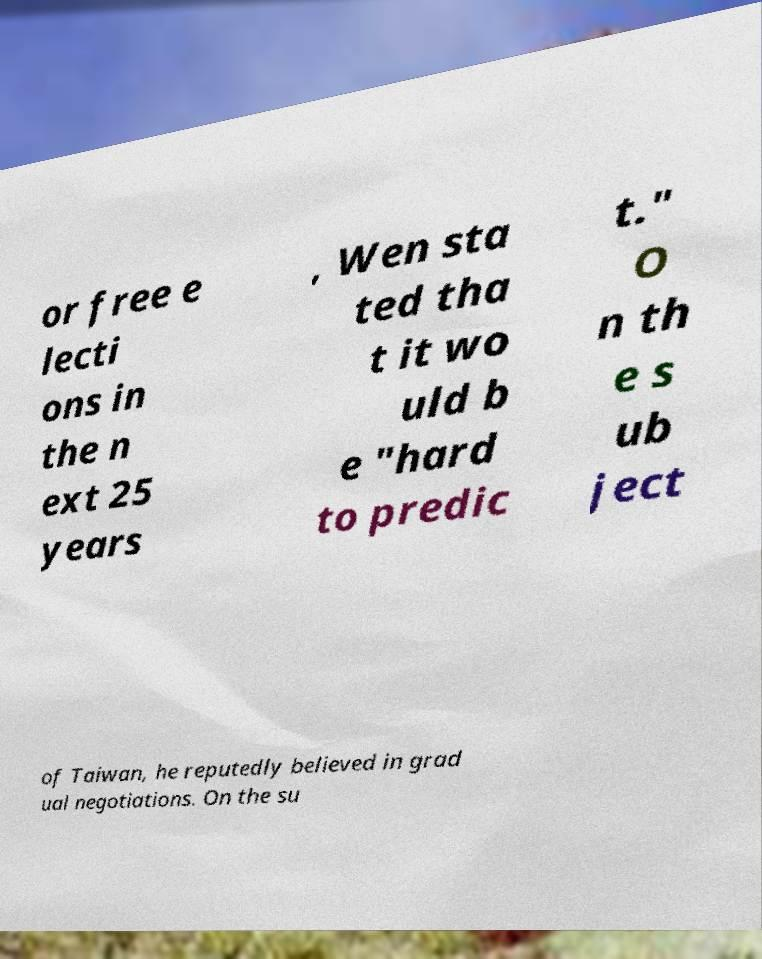Could you extract and type out the text from this image? or free e lecti ons in the n ext 25 years , Wen sta ted tha t it wo uld b e "hard to predic t." O n th e s ub ject of Taiwan, he reputedly believed in grad ual negotiations. On the su 